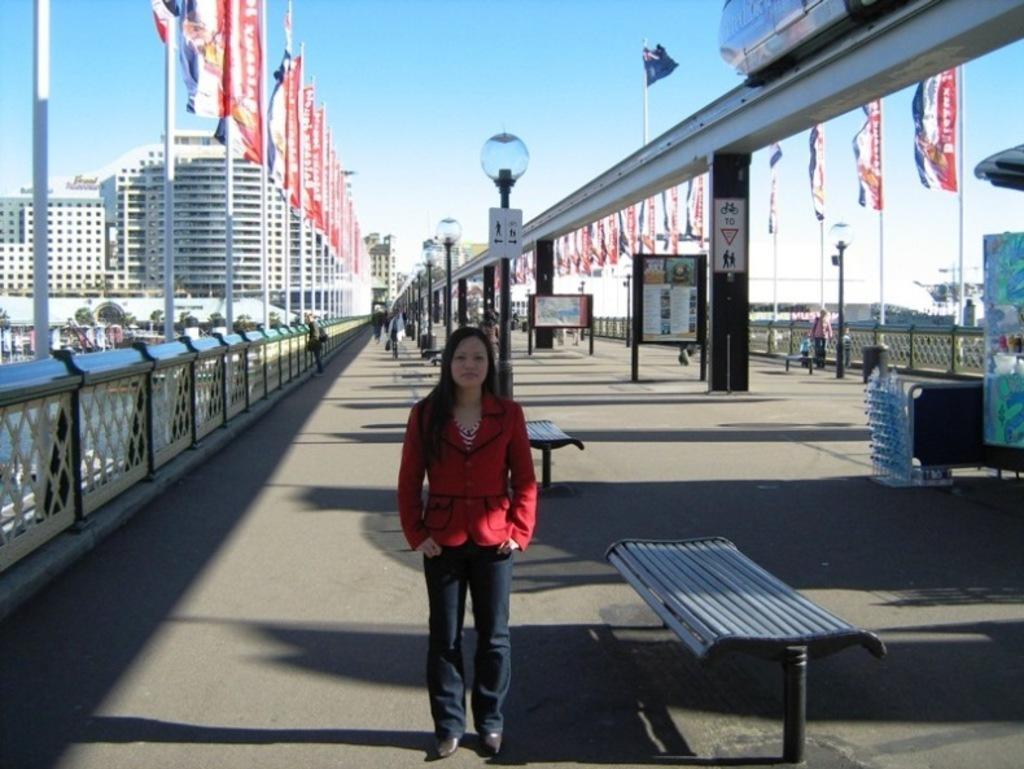How would you summarize this image in a sentence or two? There is a girl walking on road and behind her there is a stall and and display board. there are flags on the poles on corner of road. 